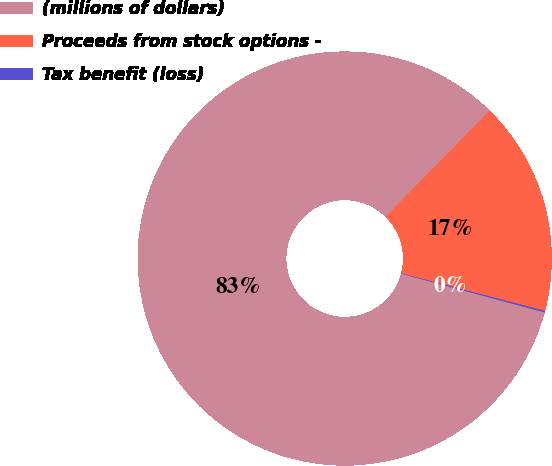<chart> <loc_0><loc_0><loc_500><loc_500><pie_chart><fcel>(millions of dollars)<fcel>Proceeds from stock options -<fcel>Tax benefit (loss)<nl><fcel>83.15%<fcel>16.73%<fcel>0.12%<nl></chart> 